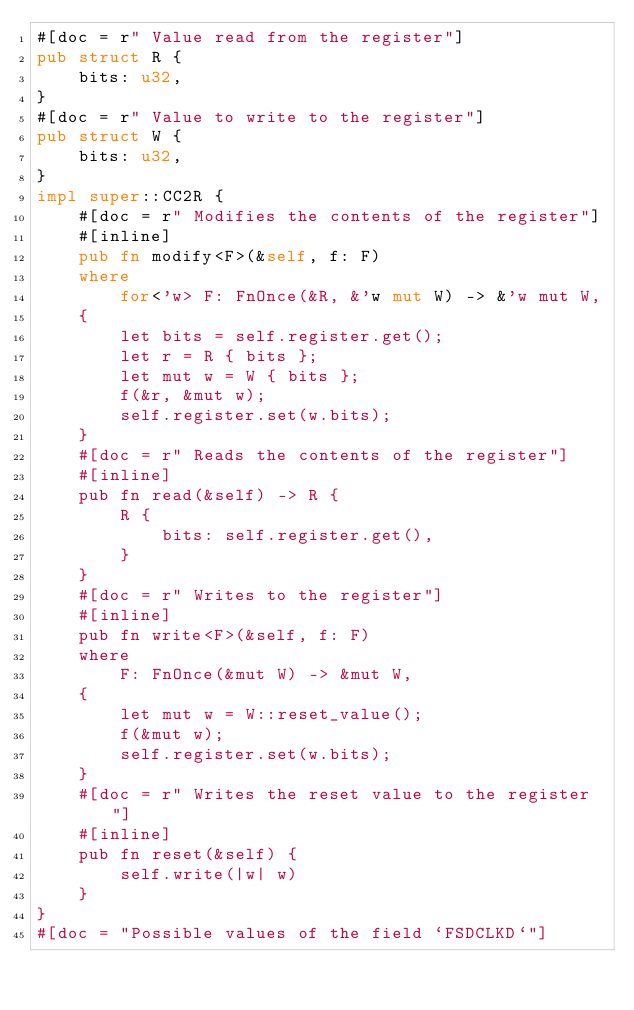<code> <loc_0><loc_0><loc_500><loc_500><_Rust_>#[doc = r" Value read from the register"]
pub struct R {
    bits: u32,
}
#[doc = r" Value to write to the register"]
pub struct W {
    bits: u32,
}
impl super::CC2R {
    #[doc = r" Modifies the contents of the register"]
    #[inline]
    pub fn modify<F>(&self, f: F)
    where
        for<'w> F: FnOnce(&R, &'w mut W) -> &'w mut W,
    {
        let bits = self.register.get();
        let r = R { bits };
        let mut w = W { bits };
        f(&r, &mut w);
        self.register.set(w.bits);
    }
    #[doc = r" Reads the contents of the register"]
    #[inline]
    pub fn read(&self) -> R {
        R {
            bits: self.register.get(),
        }
    }
    #[doc = r" Writes to the register"]
    #[inline]
    pub fn write<F>(&self, f: F)
    where
        F: FnOnce(&mut W) -> &mut W,
    {
        let mut w = W::reset_value();
        f(&mut w);
        self.register.set(w.bits);
    }
    #[doc = r" Writes the reset value to the register"]
    #[inline]
    pub fn reset(&self) {
        self.write(|w| w)
    }
}
#[doc = "Possible values of the field `FSDCLKD`"]</code> 